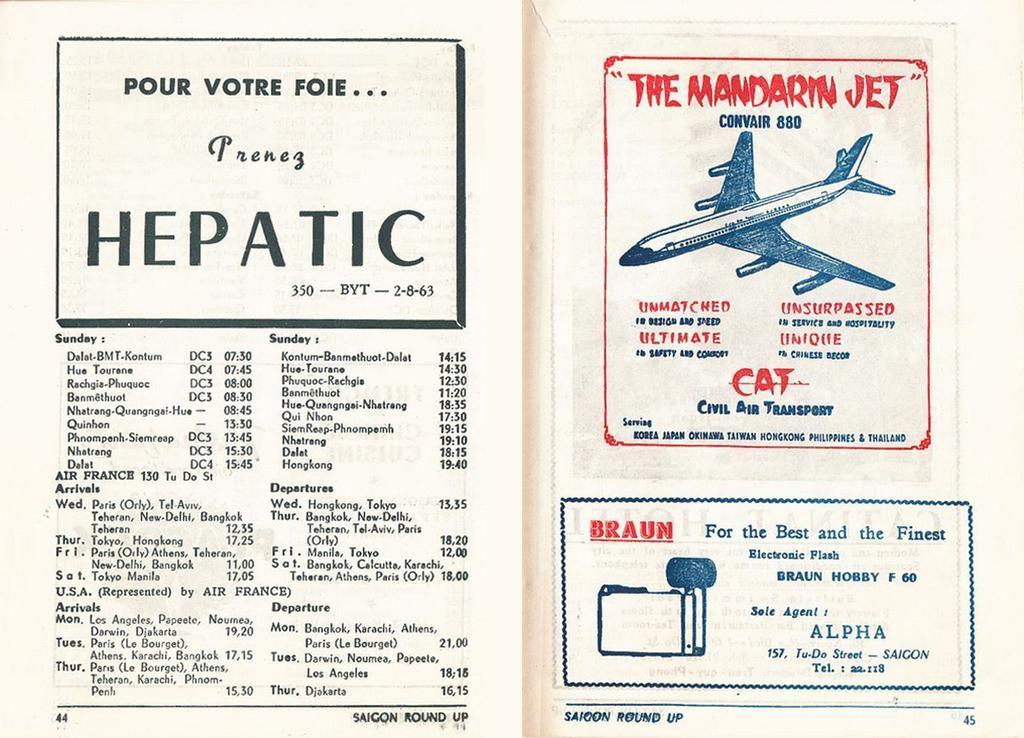Can you describe this image briefly? This is the poster of the text book as we can see page numbers on the bottom. In this poster there is some text, numbers, boxes and symbols printed on it. 